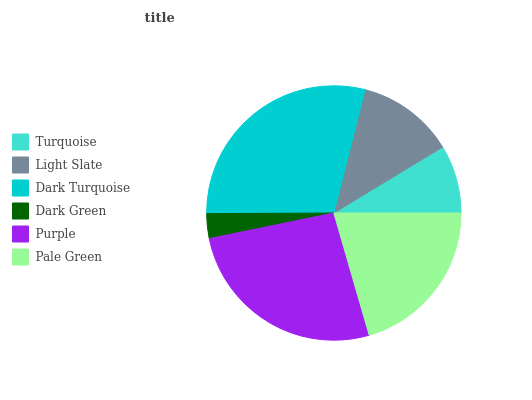Is Dark Green the minimum?
Answer yes or no. Yes. Is Dark Turquoise the maximum?
Answer yes or no. Yes. Is Light Slate the minimum?
Answer yes or no. No. Is Light Slate the maximum?
Answer yes or no. No. Is Light Slate greater than Turquoise?
Answer yes or no. Yes. Is Turquoise less than Light Slate?
Answer yes or no. Yes. Is Turquoise greater than Light Slate?
Answer yes or no. No. Is Light Slate less than Turquoise?
Answer yes or no. No. Is Pale Green the high median?
Answer yes or no. Yes. Is Light Slate the low median?
Answer yes or no. Yes. Is Purple the high median?
Answer yes or no. No. Is Dark Turquoise the low median?
Answer yes or no. No. 